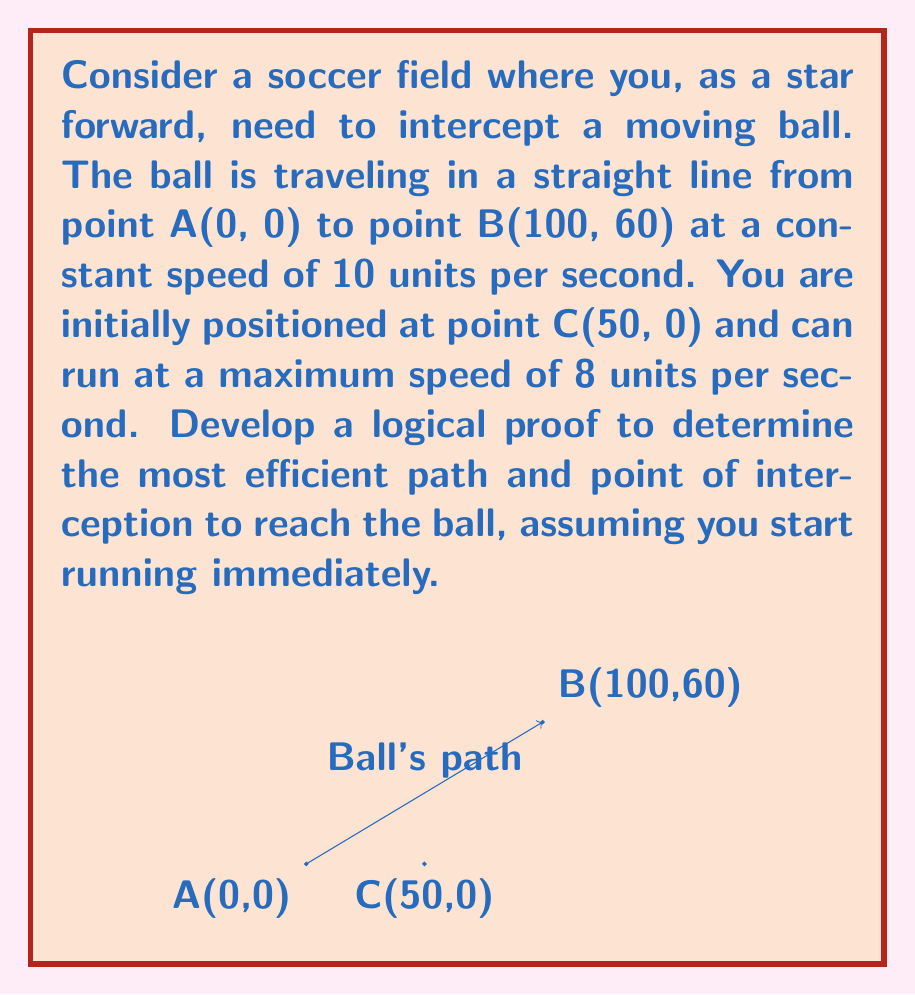Teach me how to tackle this problem. To solve this problem, we'll use the following logical steps:

1. Define the ball's position as a function of time:
   Let $t$ be the time in seconds. The ball's position at time $t$ is:
   $$x_b(t) = 10t, y_b(t) = 6t$$

2. Define your position as a function of time and angle:
   Let $\theta$ be the angle at which you run (measured from the x-axis).
   Your position at time $t$ is:
   $$x_p(t) = 50 + 8t\cos(\theta), y_p(t) = 8t\sin(\theta)$$

3. For interception, your position must equal the ball's position at some time $t$:
   $$50 + 8t\cos(\theta) = 10t$$
   $$8t\sin(\theta) = 6t$$

4. From the second equation:
   $$\sin(\theta) = \frac{3}{4}$$
   $$\theta = \arcsin(\frac{3}{4}) \approx 0.8481 \text{ radians}$$

5. Substituting this into the first equation:
   $$50 + 8t\cos(\arcsin(\frac{3}{4})) = 10t$$
   $$50 + 8t\cdot\frac{5}{8} = 10t$$
   $$50 = 5t/2$$
   $$t = 20 \text{ seconds}$$

6. The interception point is:
   $$x = 10t = 200, y = 6t = 120$$

7. To prove this is the most efficient path:
   - Any other angle would result in a longer interception time.
   - A longer time means the ball travels further, requiring you to run a greater distance.
   - Therefore, this path minimizes both time and distance, making it the most efficient.
Answer: The most efficient path to intercept the ball is to run at an angle of $\theta = \arcsin(\frac{3}{4}) \approx 0.8481$ radians from the x-axis. The interception point is (200, 120), reached after 20 seconds. 